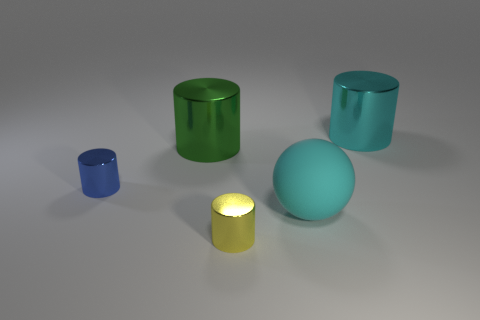Subtract 1 cylinders. How many cylinders are left? 3 Add 4 big spheres. How many objects exist? 9 Subtract all cylinders. How many objects are left? 1 Add 2 big green balls. How many big green balls exist? 2 Subtract 1 cyan cylinders. How many objects are left? 4 Subtract all purple shiny blocks. Subtract all balls. How many objects are left? 4 Add 5 big green metal objects. How many big green metal objects are left? 6 